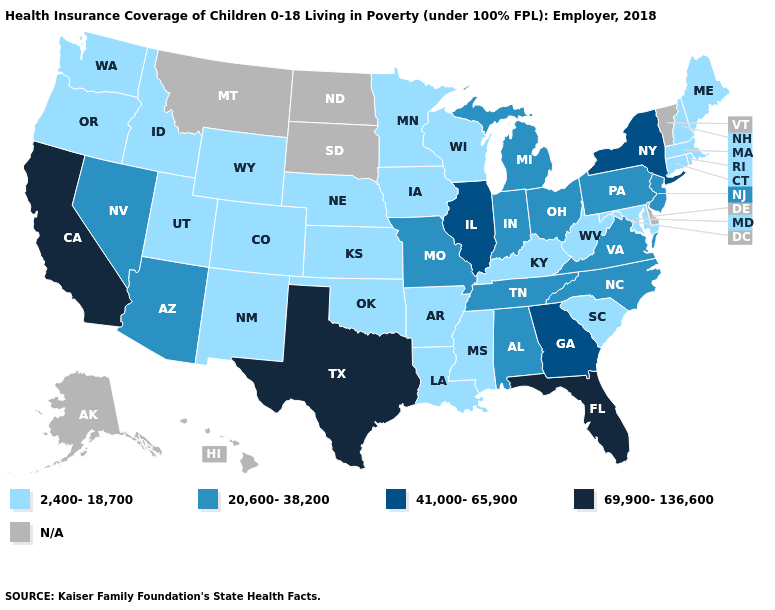What is the highest value in the West ?
Concise answer only. 69,900-136,600. Does the first symbol in the legend represent the smallest category?
Quick response, please. Yes. Which states hav the highest value in the MidWest?
Answer briefly. Illinois. Among the states that border New Hampshire , which have the lowest value?
Give a very brief answer. Maine, Massachusetts. What is the value of Iowa?
Short answer required. 2,400-18,700. What is the highest value in states that border Nebraska?
Short answer required. 20,600-38,200. Which states have the lowest value in the USA?
Quick response, please. Arkansas, Colorado, Connecticut, Idaho, Iowa, Kansas, Kentucky, Louisiana, Maine, Maryland, Massachusetts, Minnesota, Mississippi, Nebraska, New Hampshire, New Mexico, Oklahoma, Oregon, Rhode Island, South Carolina, Utah, Washington, West Virginia, Wisconsin, Wyoming. What is the highest value in the MidWest ?
Be succinct. 41,000-65,900. Name the states that have a value in the range 20,600-38,200?
Concise answer only. Alabama, Arizona, Indiana, Michigan, Missouri, Nevada, New Jersey, North Carolina, Ohio, Pennsylvania, Tennessee, Virginia. What is the value of South Carolina?
Quick response, please. 2,400-18,700. What is the highest value in the MidWest ?
Concise answer only. 41,000-65,900. Does New Jersey have the lowest value in the Northeast?
Short answer required. No. What is the value of Alaska?
Concise answer only. N/A. 